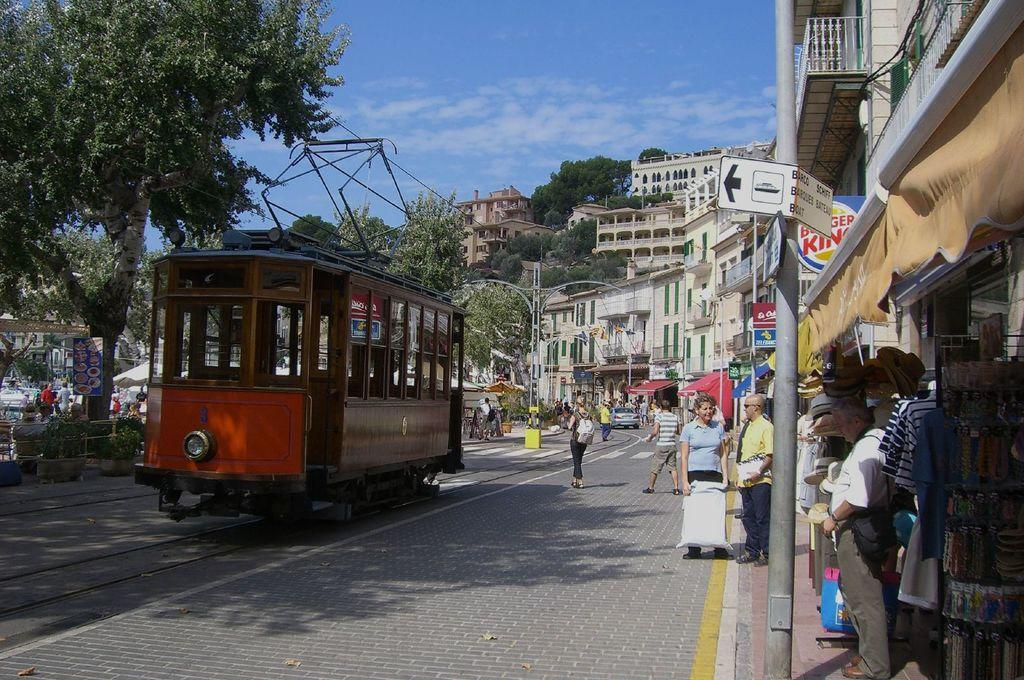<image>
Describe the image concisely. A trolley passes by a station of some sort that may be a area to get to the ferries, sign barely readable says barco and schiff 